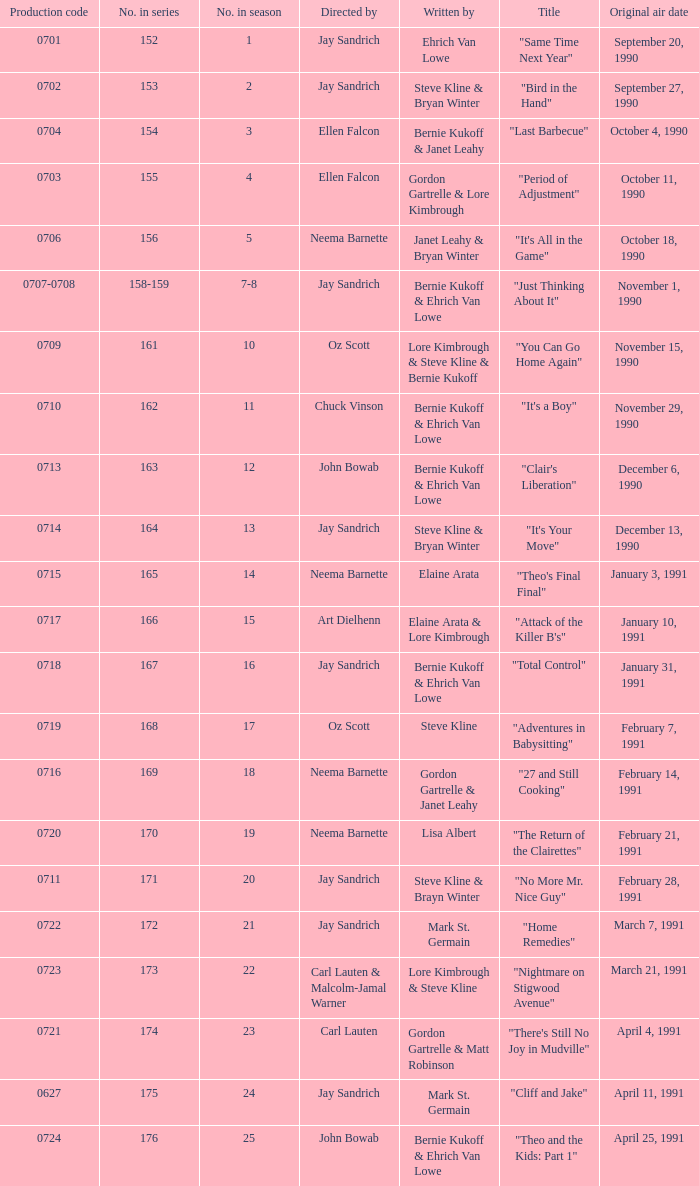The episode directed by art dielhenn was what number in the series?  166.0. 